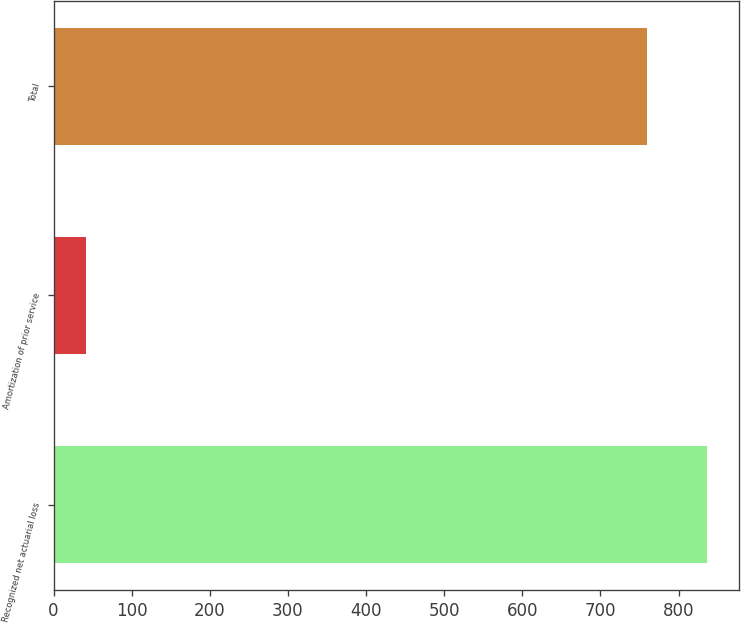<chart> <loc_0><loc_0><loc_500><loc_500><bar_chart><fcel>Recognized net actuarial loss<fcel>Amortization of prior service<fcel>Total<nl><fcel>836<fcel>41<fcel>760<nl></chart> 